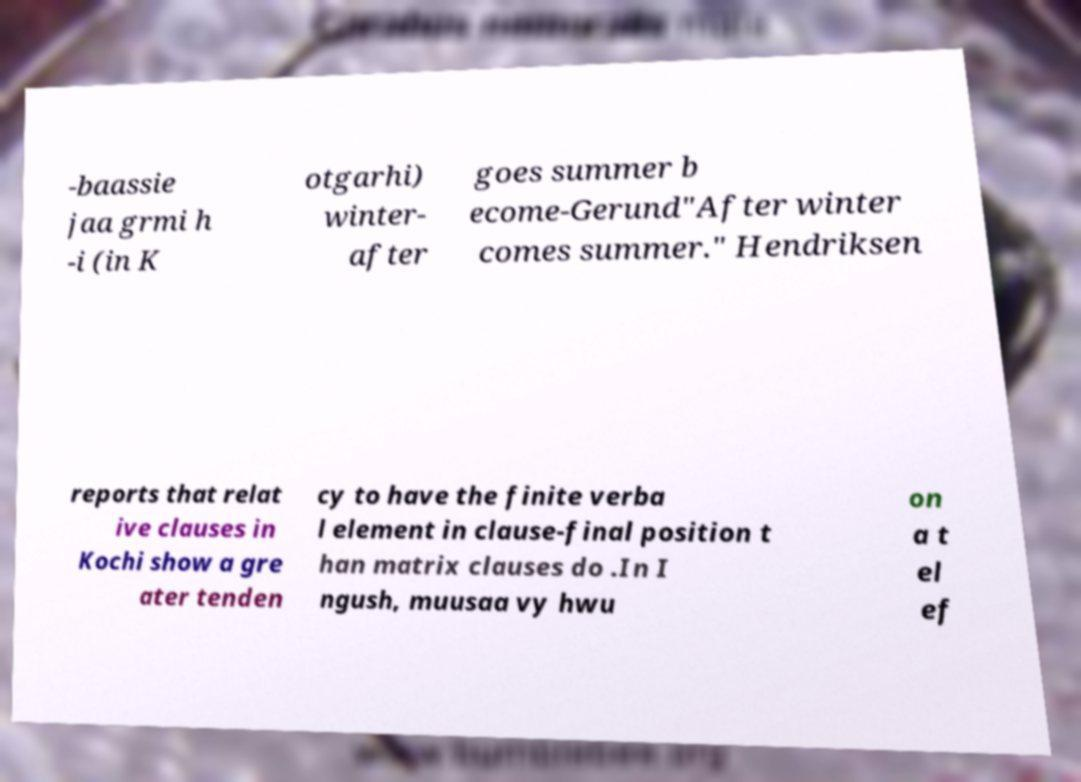I need the written content from this picture converted into text. Can you do that? -baassie jaa grmi h -i (in K otgarhi) winter- after goes summer b ecome-Gerund"After winter comes summer." Hendriksen reports that relat ive clauses in Kochi show a gre ater tenden cy to have the finite verba l element in clause-final position t han matrix clauses do .In I ngush, muusaa vy hwu on a t el ef 